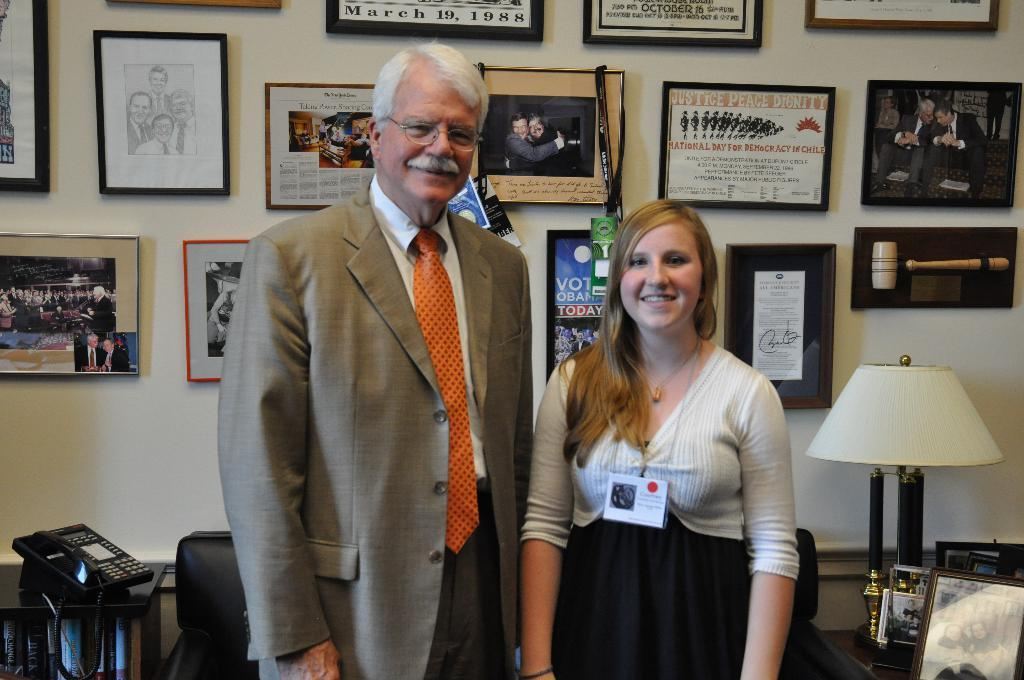<image>
Give a short and clear explanation of the subsequent image. A man and woman in an office and there is a framed justice peace dignity sign. 